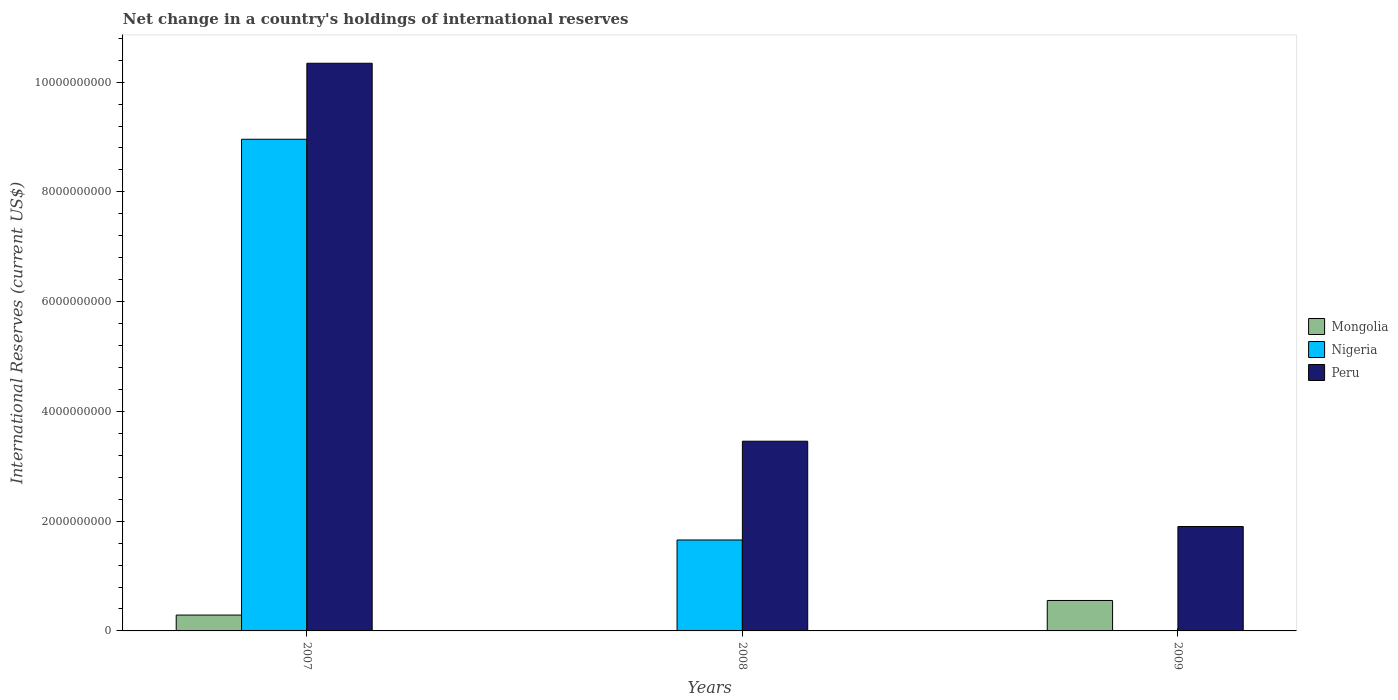How many different coloured bars are there?
Your answer should be compact. 3. How many groups of bars are there?
Ensure brevity in your answer.  3. Are the number of bars per tick equal to the number of legend labels?
Ensure brevity in your answer.  No. How many bars are there on the 1st tick from the right?
Offer a very short reply. 2. What is the international reserves in Peru in 2007?
Give a very brief answer. 1.03e+1. Across all years, what is the maximum international reserves in Nigeria?
Ensure brevity in your answer.  8.96e+09. Across all years, what is the minimum international reserves in Nigeria?
Make the answer very short. 0. In which year was the international reserves in Nigeria maximum?
Offer a terse response. 2007. What is the total international reserves in Peru in the graph?
Your answer should be very brief. 1.57e+1. What is the difference between the international reserves in Peru in 2007 and that in 2009?
Your answer should be compact. 8.44e+09. What is the difference between the international reserves in Mongolia in 2008 and the international reserves in Nigeria in 2007?
Offer a terse response. -8.96e+09. What is the average international reserves in Mongolia per year?
Offer a terse response. 2.81e+08. In the year 2007, what is the difference between the international reserves in Peru and international reserves in Mongolia?
Keep it short and to the point. 1.01e+1. What is the ratio of the international reserves in Peru in 2008 to that in 2009?
Provide a short and direct response. 1.82. What is the difference between the highest and the second highest international reserves in Peru?
Offer a very short reply. 6.89e+09. What is the difference between the highest and the lowest international reserves in Mongolia?
Give a very brief answer. 5.55e+08. Is the sum of the international reserves in Peru in 2007 and 2009 greater than the maximum international reserves in Mongolia across all years?
Your answer should be very brief. Yes. Is it the case that in every year, the sum of the international reserves in Peru and international reserves in Nigeria is greater than the international reserves in Mongolia?
Provide a short and direct response. Yes. How many bars are there?
Your answer should be compact. 7. What is the difference between two consecutive major ticks on the Y-axis?
Offer a very short reply. 2.00e+09. Are the values on the major ticks of Y-axis written in scientific E-notation?
Provide a succinct answer. No. How many legend labels are there?
Your answer should be compact. 3. What is the title of the graph?
Offer a very short reply. Net change in a country's holdings of international reserves. Does "Europe(developing only)" appear as one of the legend labels in the graph?
Make the answer very short. No. What is the label or title of the X-axis?
Offer a very short reply. Years. What is the label or title of the Y-axis?
Provide a short and direct response. International Reserves (current US$). What is the International Reserves (current US$) of Mongolia in 2007?
Make the answer very short. 2.89e+08. What is the International Reserves (current US$) of Nigeria in 2007?
Make the answer very short. 8.96e+09. What is the International Reserves (current US$) in Peru in 2007?
Provide a short and direct response. 1.03e+1. What is the International Reserves (current US$) of Mongolia in 2008?
Make the answer very short. 0. What is the International Reserves (current US$) in Nigeria in 2008?
Offer a very short reply. 1.66e+09. What is the International Reserves (current US$) in Peru in 2008?
Ensure brevity in your answer.  3.46e+09. What is the International Reserves (current US$) of Mongolia in 2009?
Provide a short and direct response. 5.55e+08. What is the International Reserves (current US$) in Peru in 2009?
Keep it short and to the point. 1.90e+09. Across all years, what is the maximum International Reserves (current US$) of Mongolia?
Keep it short and to the point. 5.55e+08. Across all years, what is the maximum International Reserves (current US$) in Nigeria?
Offer a terse response. 8.96e+09. Across all years, what is the maximum International Reserves (current US$) of Peru?
Ensure brevity in your answer.  1.03e+1. Across all years, what is the minimum International Reserves (current US$) of Peru?
Your answer should be compact. 1.90e+09. What is the total International Reserves (current US$) of Mongolia in the graph?
Give a very brief answer. 8.44e+08. What is the total International Reserves (current US$) in Nigeria in the graph?
Offer a very short reply. 1.06e+1. What is the total International Reserves (current US$) in Peru in the graph?
Your answer should be compact. 1.57e+1. What is the difference between the International Reserves (current US$) in Nigeria in 2007 and that in 2008?
Your answer should be compact. 7.30e+09. What is the difference between the International Reserves (current US$) in Peru in 2007 and that in 2008?
Your response must be concise. 6.89e+09. What is the difference between the International Reserves (current US$) of Mongolia in 2007 and that in 2009?
Give a very brief answer. -2.66e+08. What is the difference between the International Reserves (current US$) in Peru in 2007 and that in 2009?
Offer a terse response. 8.44e+09. What is the difference between the International Reserves (current US$) in Peru in 2008 and that in 2009?
Your answer should be very brief. 1.55e+09. What is the difference between the International Reserves (current US$) in Mongolia in 2007 and the International Reserves (current US$) in Nigeria in 2008?
Keep it short and to the point. -1.37e+09. What is the difference between the International Reserves (current US$) in Mongolia in 2007 and the International Reserves (current US$) in Peru in 2008?
Make the answer very short. -3.17e+09. What is the difference between the International Reserves (current US$) of Nigeria in 2007 and the International Reserves (current US$) of Peru in 2008?
Your response must be concise. 5.50e+09. What is the difference between the International Reserves (current US$) of Mongolia in 2007 and the International Reserves (current US$) of Peru in 2009?
Give a very brief answer. -1.61e+09. What is the difference between the International Reserves (current US$) in Nigeria in 2007 and the International Reserves (current US$) in Peru in 2009?
Ensure brevity in your answer.  7.06e+09. What is the difference between the International Reserves (current US$) in Nigeria in 2008 and the International Reserves (current US$) in Peru in 2009?
Give a very brief answer. -2.45e+08. What is the average International Reserves (current US$) of Mongolia per year?
Your answer should be compact. 2.81e+08. What is the average International Reserves (current US$) in Nigeria per year?
Provide a short and direct response. 3.54e+09. What is the average International Reserves (current US$) of Peru per year?
Make the answer very short. 5.23e+09. In the year 2007, what is the difference between the International Reserves (current US$) in Mongolia and International Reserves (current US$) in Nigeria?
Keep it short and to the point. -8.67e+09. In the year 2007, what is the difference between the International Reserves (current US$) of Mongolia and International Reserves (current US$) of Peru?
Provide a short and direct response. -1.01e+1. In the year 2007, what is the difference between the International Reserves (current US$) in Nigeria and International Reserves (current US$) in Peru?
Your response must be concise. -1.38e+09. In the year 2008, what is the difference between the International Reserves (current US$) in Nigeria and International Reserves (current US$) in Peru?
Provide a short and direct response. -1.80e+09. In the year 2009, what is the difference between the International Reserves (current US$) in Mongolia and International Reserves (current US$) in Peru?
Provide a short and direct response. -1.35e+09. What is the ratio of the International Reserves (current US$) in Nigeria in 2007 to that in 2008?
Keep it short and to the point. 5.41. What is the ratio of the International Reserves (current US$) of Peru in 2007 to that in 2008?
Offer a very short reply. 2.99. What is the ratio of the International Reserves (current US$) in Mongolia in 2007 to that in 2009?
Your answer should be very brief. 0.52. What is the ratio of the International Reserves (current US$) in Peru in 2007 to that in 2009?
Make the answer very short. 5.44. What is the ratio of the International Reserves (current US$) in Peru in 2008 to that in 2009?
Your response must be concise. 1.82. What is the difference between the highest and the second highest International Reserves (current US$) in Peru?
Make the answer very short. 6.89e+09. What is the difference between the highest and the lowest International Reserves (current US$) in Mongolia?
Give a very brief answer. 5.55e+08. What is the difference between the highest and the lowest International Reserves (current US$) of Nigeria?
Make the answer very short. 8.96e+09. What is the difference between the highest and the lowest International Reserves (current US$) in Peru?
Your response must be concise. 8.44e+09. 